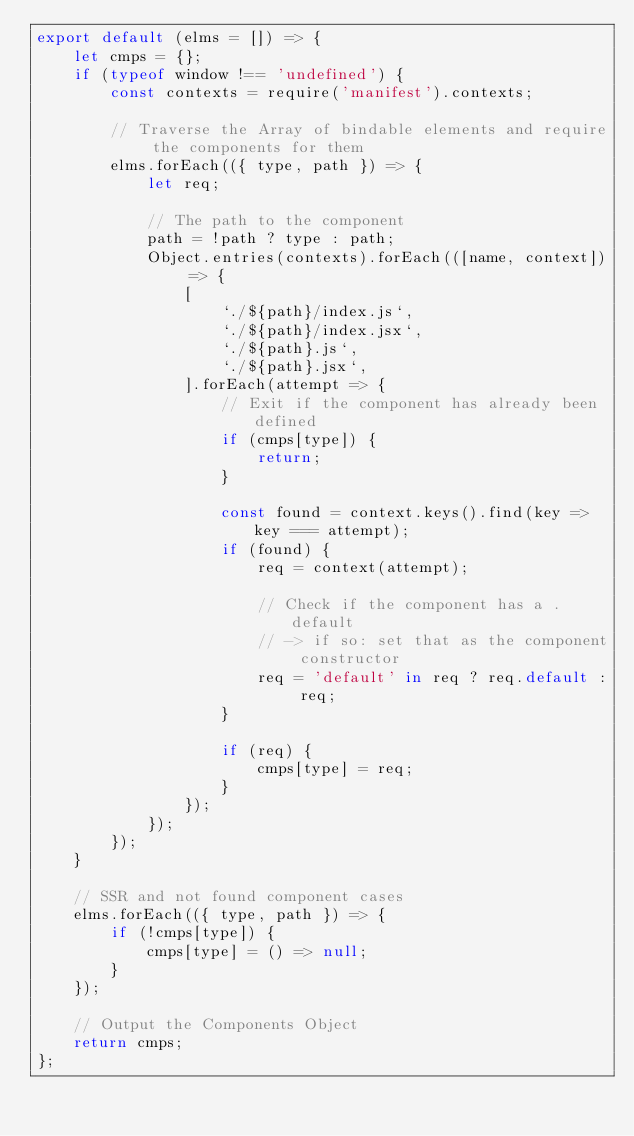Convert code to text. <code><loc_0><loc_0><loc_500><loc_500><_JavaScript_>export default (elms = []) => {
    let cmps = {};
    if (typeof window !== 'undefined') {
        const contexts = require('manifest').contexts;

        // Traverse the Array of bindable elements and require the components for them
        elms.forEach(({ type, path }) => {
            let req;

            // The path to the component
            path = !path ? type : path;
            Object.entries(contexts).forEach(([name, context]) => {
                [
                    `./${path}/index.js`,
                    `./${path}/index.jsx`,
                    `./${path}.js`,
                    `./${path}.jsx`,
                ].forEach(attempt => {
                    // Exit if the component has already been defined
                    if (cmps[type]) {
                        return;
                    }

                    const found = context.keys().find(key => key === attempt);
                    if (found) {
                        req = context(attempt);

                        // Check if the component has a .default
                        // -> if so: set that as the component constructor
                        req = 'default' in req ? req.default : req;
                    }

                    if (req) {
                        cmps[type] = req;
                    }
                });
            });
        });
    }

    // SSR and not found component cases
    elms.forEach(({ type, path }) => {
        if (!cmps[type]) {
            cmps[type] = () => null;
        }
    });

    // Output the Components Object
    return cmps;
};
</code> 